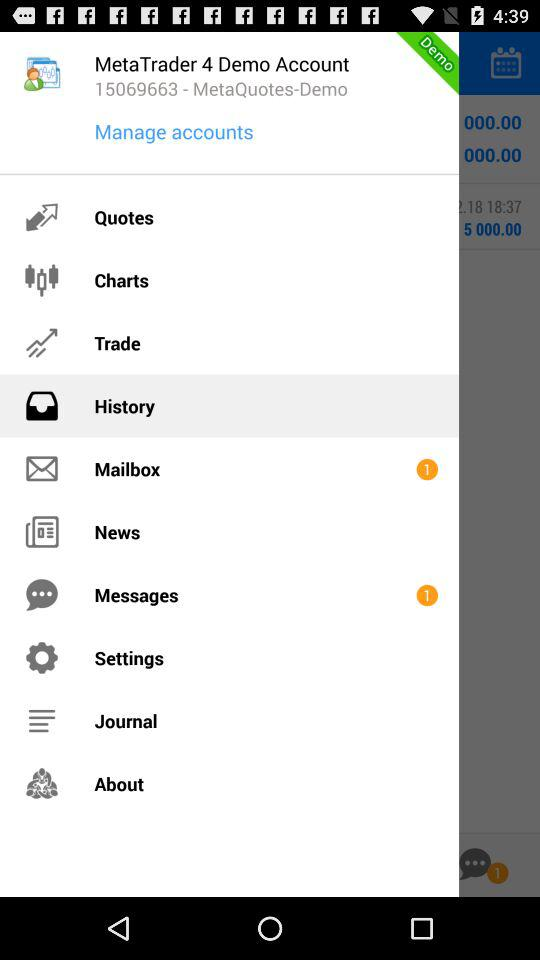Which item is selected in the menu? The selected item in the menu is "History". 